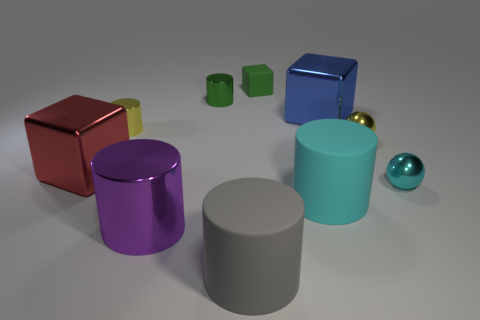Subtract all small cylinders. How many cylinders are left? 3 Subtract all yellow balls. How many balls are left? 1 Subtract 2 cylinders. How many cylinders are left? 3 Subtract all balls. How many objects are left? 8 Subtract all gray cubes. Subtract all brown cylinders. How many cubes are left? 3 Subtract all cyan cubes. How many cyan spheres are left? 1 Subtract all tiny brown metallic things. Subtract all small yellow metal things. How many objects are left? 8 Add 1 metallic objects. How many metallic objects are left? 8 Add 1 tiny green blocks. How many tiny green blocks exist? 2 Subtract 0 yellow blocks. How many objects are left? 10 